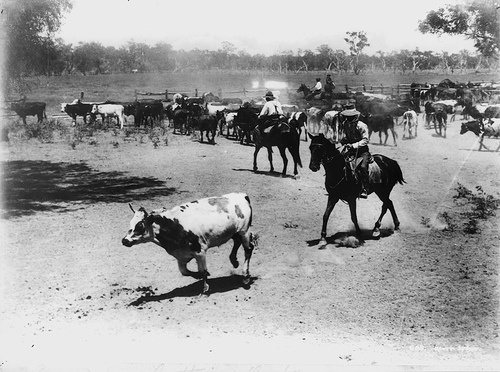Describe the objects in this image and their specific colors. I can see cow in lightgray, black, darkgray, and gray tones, horse in lightgray, black, gray, and darkgray tones, horse in lightgray, black, gray, and darkgray tones, people in lightgray, black, gray, and darkgray tones, and cow in lightgray, black, gray, darkgray, and gainsboro tones in this image. 